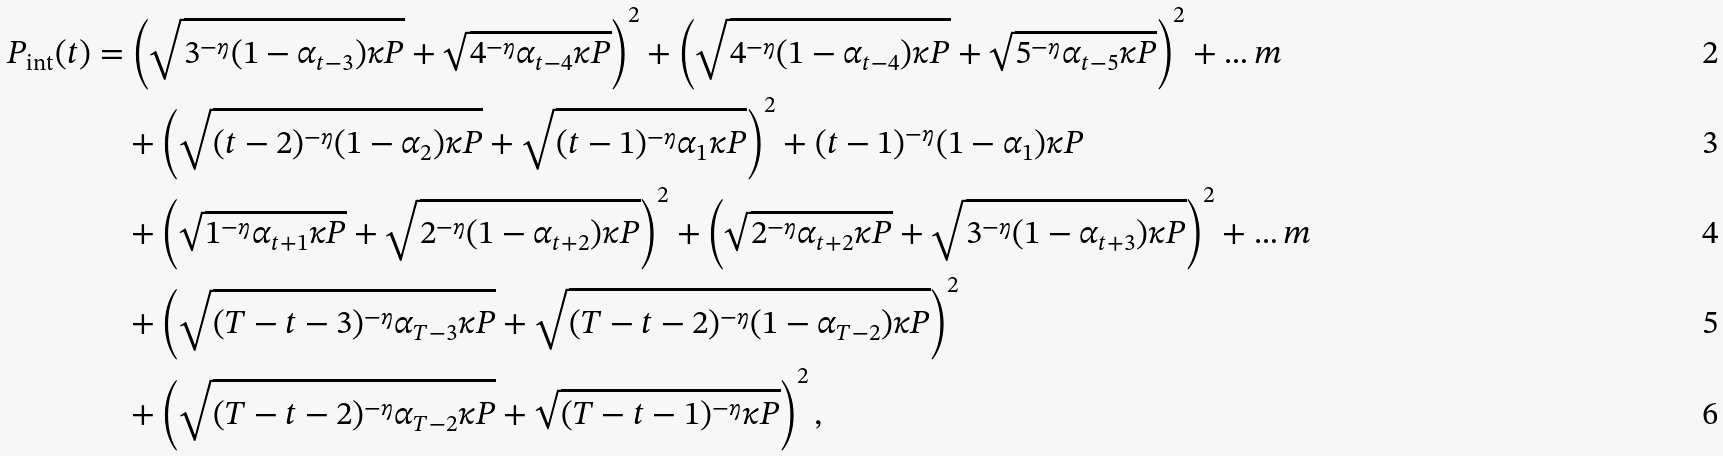Convert formula to latex. <formula><loc_0><loc_0><loc_500><loc_500>P _ { \text {int} } ( t ) & = \left ( \sqrt { 3 ^ { - \eta } ( 1 - \alpha _ { t - 3 } ) \kappa P } + \sqrt { 4 ^ { - \eta } \alpha _ { t - 4 } \kappa P } \right ) ^ { 2 } + \left ( \sqrt { 4 ^ { - \eta } ( 1 - \alpha _ { t - 4 } ) \kappa P } + \sqrt { 5 ^ { - \eta } \alpha _ { t - 5 } \kappa P } \right ) ^ { 2 } + \dots m \\ & \quad + \left ( \sqrt { ( t - 2 ) ^ { - \eta } ( 1 - \alpha _ { 2 } ) \kappa P } + \sqrt { ( t - 1 ) ^ { - \eta } \alpha _ { 1 } \kappa P } \right ) ^ { 2 } + ( t - 1 ) ^ { - \eta } ( 1 - \alpha _ { 1 } ) \kappa P \\ & \quad + \left ( \sqrt { 1 ^ { - \eta } \alpha _ { t + 1 } \kappa P } + \sqrt { 2 ^ { - \eta } ( 1 - \alpha _ { t + 2 } ) \kappa P } \right ) ^ { 2 } + \left ( \sqrt { 2 ^ { - \eta } \alpha _ { t + 2 } \kappa P } + \sqrt { 3 ^ { - \eta } ( 1 - \alpha _ { t + 3 } ) \kappa P } \right ) ^ { 2 } + \dots m \\ & \quad + \left ( \sqrt { ( T - t - 3 ) ^ { - \eta } \alpha _ { T - 3 } \kappa P } + \sqrt { ( T - t - 2 ) ^ { - \eta } ( 1 - \alpha _ { T - 2 } ) \kappa P } \right ) ^ { 2 } \\ & \quad + \left ( \sqrt { ( T - t - 2 ) ^ { - \eta } \alpha _ { T - 2 } \kappa P } + \sqrt { ( T - t - 1 ) ^ { - \eta } \kappa P } \right ) ^ { 2 } ,</formula> 